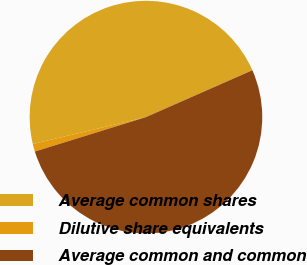Convert chart. <chart><loc_0><loc_0><loc_500><loc_500><pie_chart><fcel>Average common shares<fcel>Dilutive share equivalents<fcel>Average common and common<nl><fcel>47.11%<fcel>1.07%<fcel>51.82%<nl></chart> 